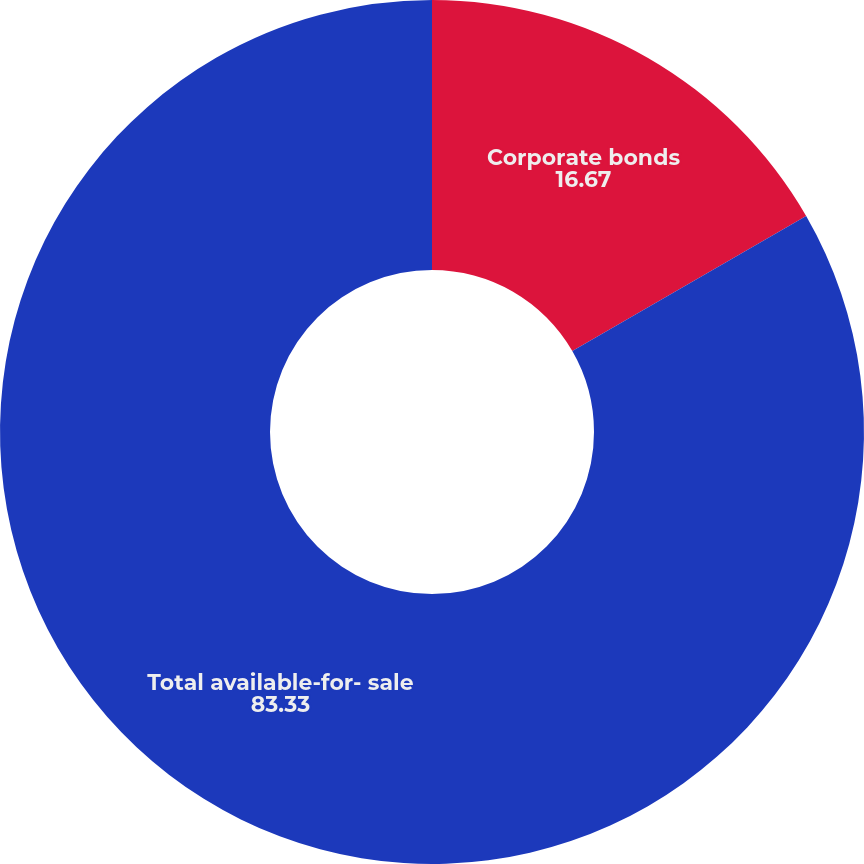<chart> <loc_0><loc_0><loc_500><loc_500><pie_chart><fcel>Corporate bonds<fcel>Total available-for- sale<nl><fcel>16.67%<fcel>83.33%<nl></chart> 